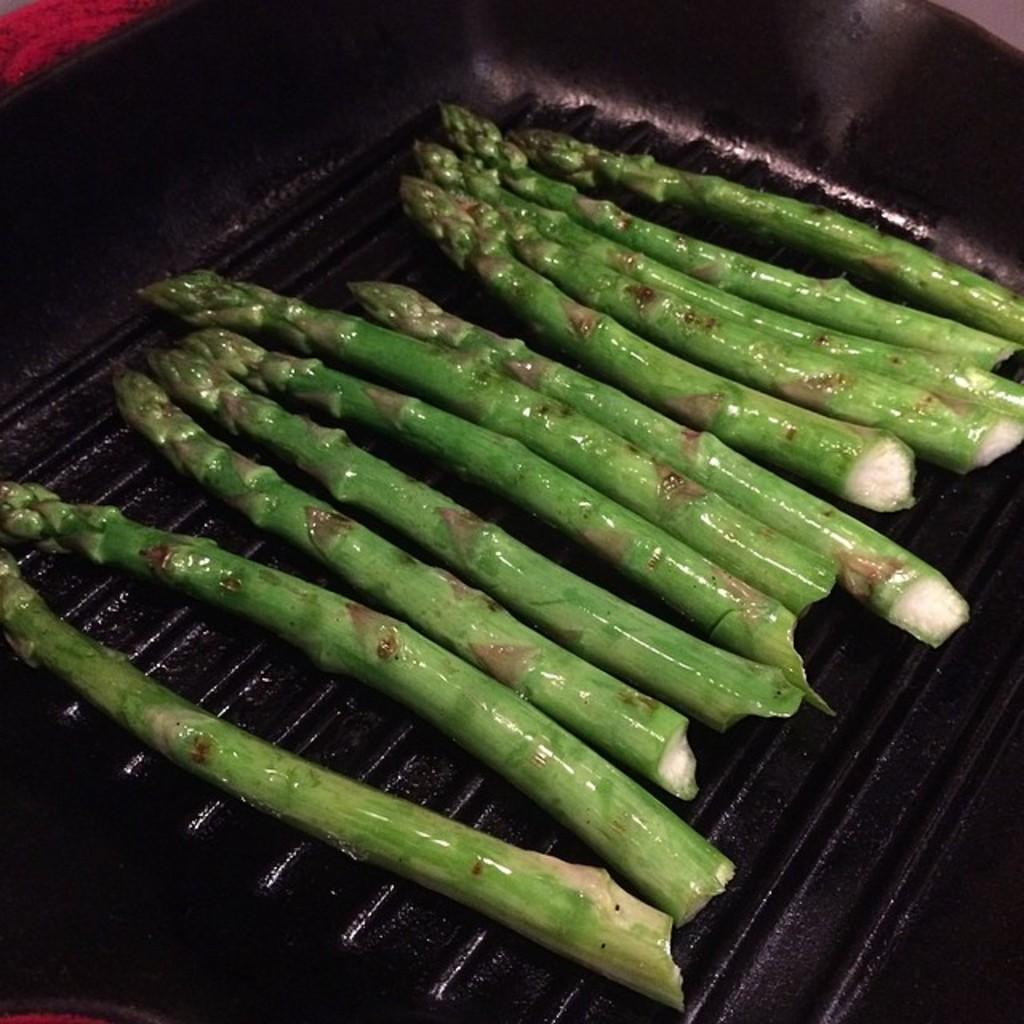What is the main subject of the image? There is a food item in the image. What is the color of the surface on which the food item is placed? The food item is on a black surface. How many people are paying attention to the food item in the image? There is no information about people or their attention in the image. What shape is the market in the image? There is no market present in the image. 